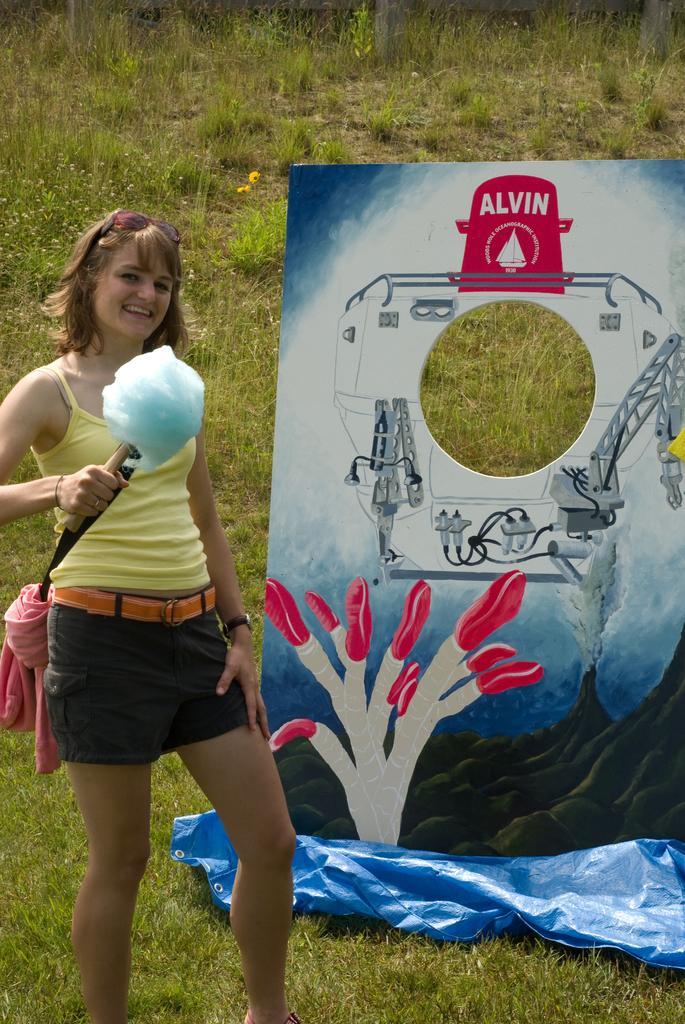Can you describe this image briefly? In the image in the center, we can see one person standing and smiling. And we can see she is holding some object. In the background we can see grass, one cloth and banner. 